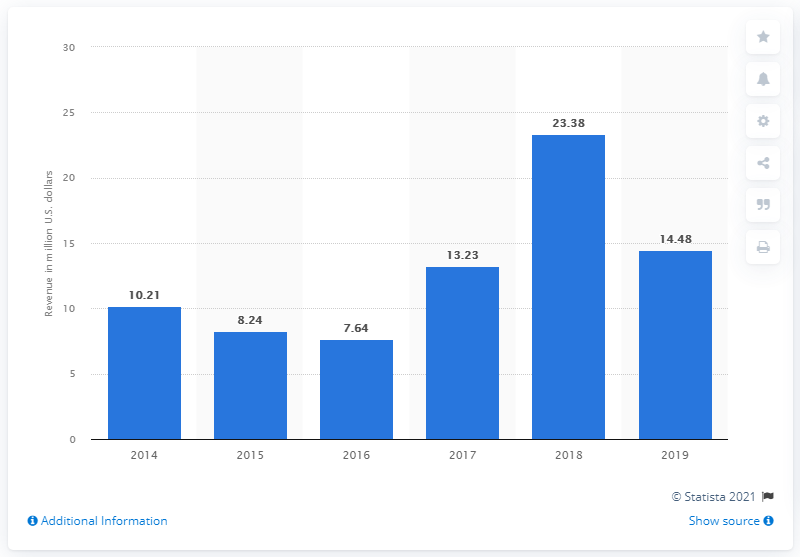Draw attention to some important aspects in this diagram. In 2019, Lollapalooza generated approximately 14.48 million dollars in revenue in the United States. 